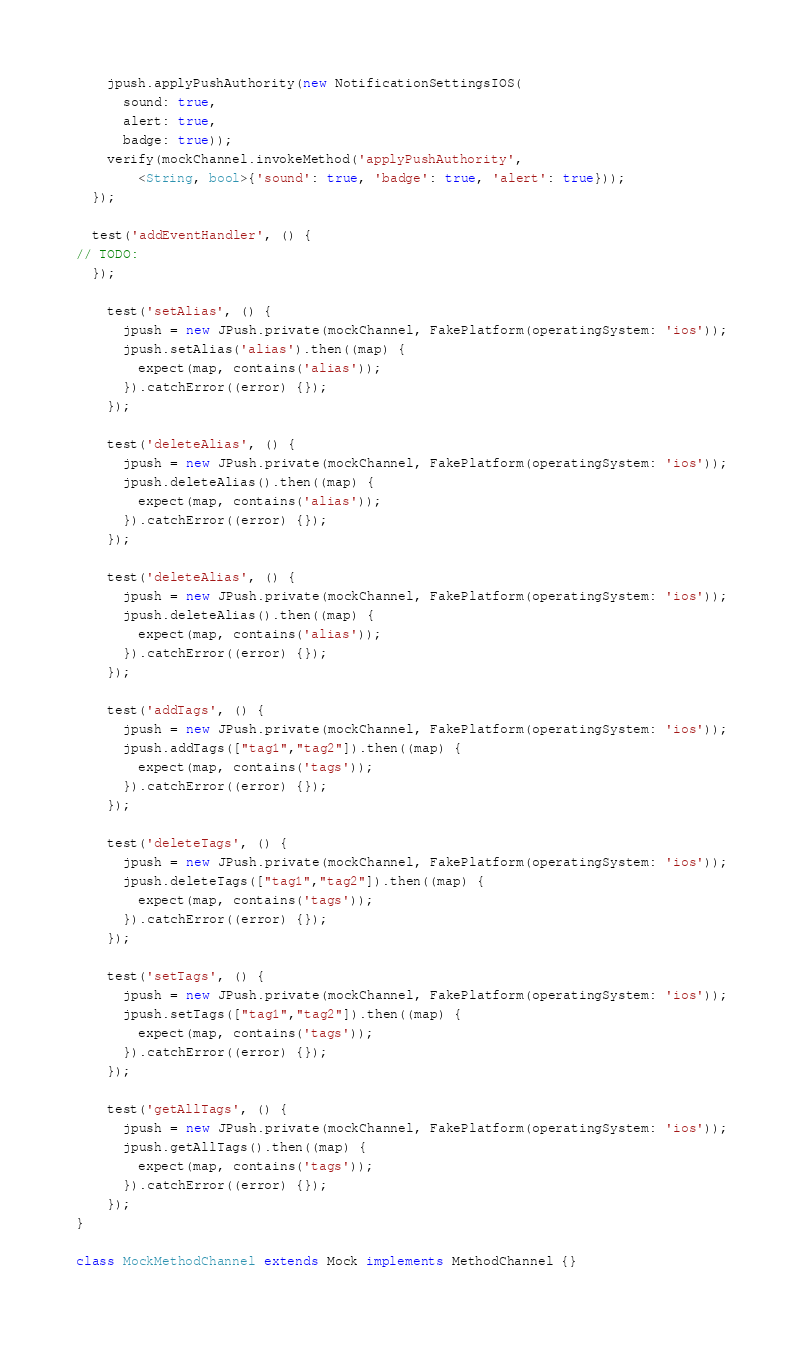<code> <loc_0><loc_0><loc_500><loc_500><_Dart_>    jpush.applyPushAuthority(new NotificationSettingsIOS(
      sound: true,
      alert: true,
      badge: true));
    verify(mockChannel.invokeMethod('applyPushAuthority',
        <String, bool>{'sound': true, 'badge': true, 'alert': true}));
  });

  test('addEventHandler', () {
// TODO:
  });

    test('setAlias', () {
      jpush = new JPush.private(mockChannel, FakePlatform(operatingSystem: 'ios'));
      jpush.setAlias('alias').then((map) {
        expect(map, contains('alias'));
      }).catchError((error) {});
    });

    test('deleteAlias', () {
      jpush = new JPush.private(mockChannel, FakePlatform(operatingSystem: 'ios'));
      jpush.deleteAlias().then((map) {
        expect(map, contains('alias'));
      }).catchError((error) {});
    });

    test('deleteAlias', () {
      jpush = new JPush.private(mockChannel, FakePlatform(operatingSystem: 'ios'));
      jpush.deleteAlias().then((map) {
        expect(map, contains('alias'));
      }).catchError((error) {});
    });

    test('addTags', () {
      jpush = new JPush.private(mockChannel, FakePlatform(operatingSystem: 'ios'));
      jpush.addTags(["tag1","tag2"]).then((map) {
        expect(map, contains('tags'));
      }).catchError((error) {});
    });
    
    test('deleteTags', () {
      jpush = new JPush.private(mockChannel, FakePlatform(operatingSystem: 'ios'));
      jpush.deleteTags(["tag1","tag2"]).then((map) {
        expect(map, contains('tags'));
      }).catchError((error) {});
    });

    test('setTags', () {
      jpush = new JPush.private(mockChannel, FakePlatform(operatingSystem: 'ios'));
      jpush.setTags(["tag1","tag2"]).then((map) {
        expect(map, contains('tags'));
      }).catchError((error) {});
    });

    test('getAllTags', () {
      jpush = new JPush.private(mockChannel, FakePlatform(operatingSystem: 'ios'));
      jpush.getAllTags().then((map) {
        expect(map, contains('tags'));
      }).catchError((error) {});
    });  
}

class MockMethodChannel extends Mock implements MethodChannel {}</code> 